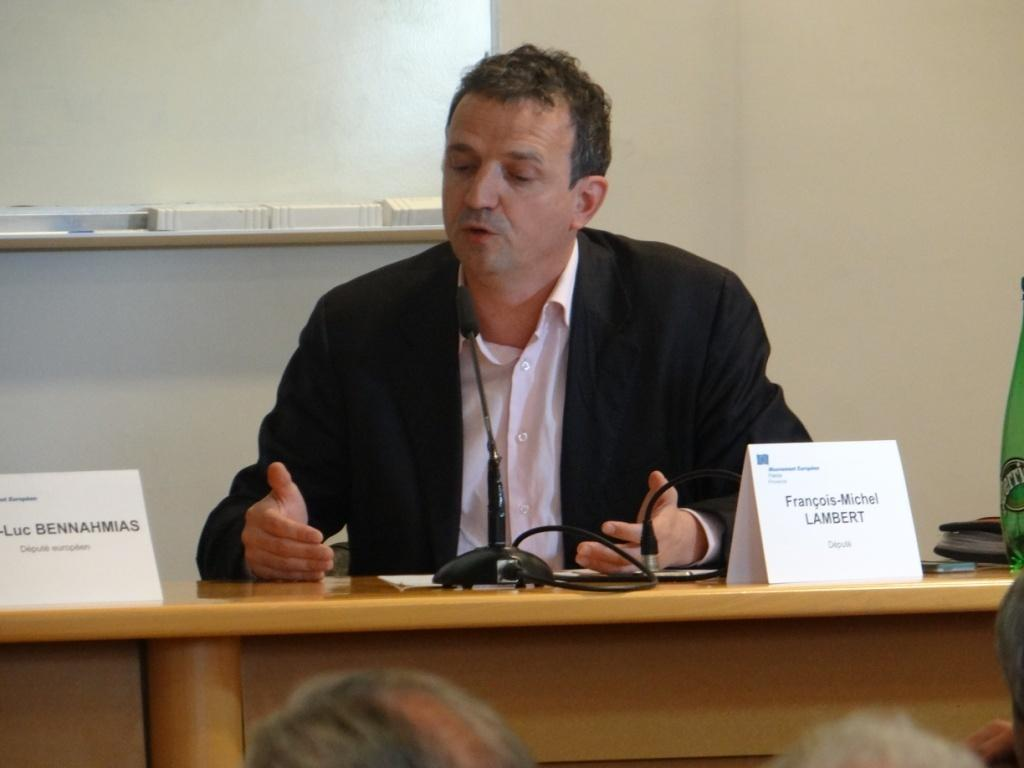What is the main subject of the image? The main subject of the image is a man. What is the man wearing in the image? The man is wearing a blazer. What is in front of the man in the image? There is a table in front of the man. What items can be seen on the table? There are cards, a microphone (mic), cables, and other objects on the table. What is visible in the background of the image? There is a wall in the background of the image. What type of frog can be seen sitting on the man's shoulder in the image? There is no frog present in the image; the man is not accompanied by any frogs. What date is marked on the calendar on the table in the image? There is no calendar present in the image; the table only contains cards, a microphone, cables, and other objects. 